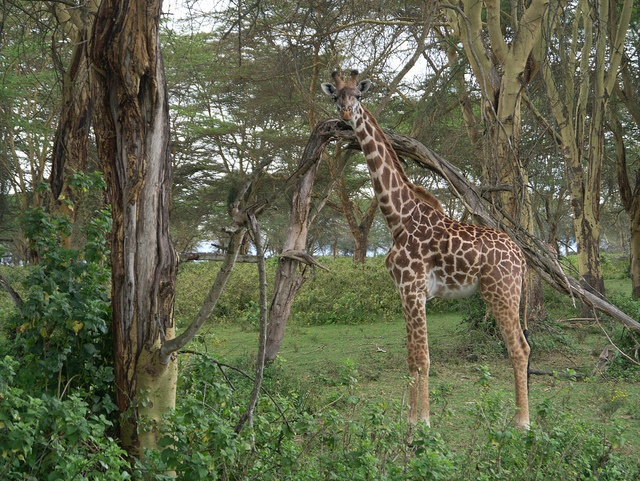Describe the objects in this image and their specific colors. I can see a giraffe in gray and maroon tones in this image. 